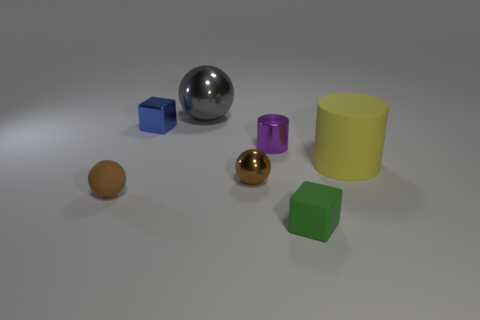Subtract all tiny balls. How many balls are left? 1 Subtract 1 balls. How many balls are left? 2 Add 3 gray metallic balls. How many objects exist? 10 Subtract all cubes. How many objects are left? 5 Add 6 tiny cyan things. How many tiny cyan things exist? 6 Subtract 0 green spheres. How many objects are left? 7 Subtract all brown metallic cylinders. Subtract all blue metal things. How many objects are left? 6 Add 2 large yellow cylinders. How many large yellow cylinders are left? 3 